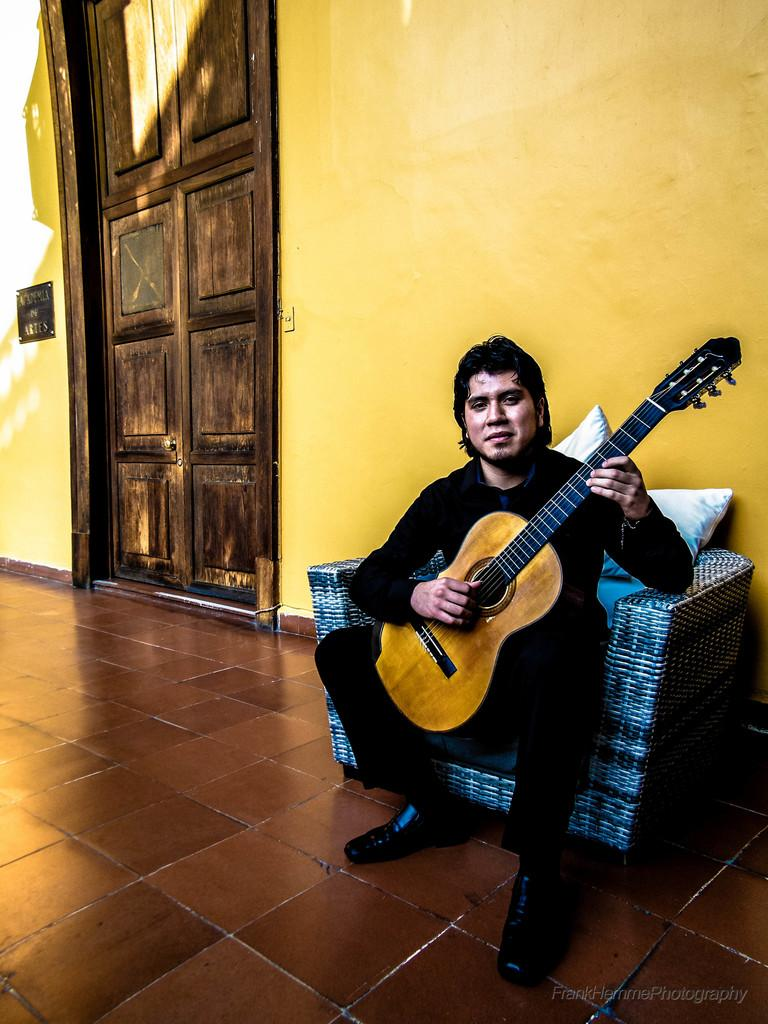Who is present in the image? There is a man in the image. What is the man doing in the image? The man is sitting on a couch and holding a guitar. What is the man wearing in the image? The man is wearing a black dress. What can be seen in the background of the image? There is a wall and a door in the background of the image. What type of tin is being distributed by the man in the image? There is no tin present in the image, nor is the man distributing anything. 